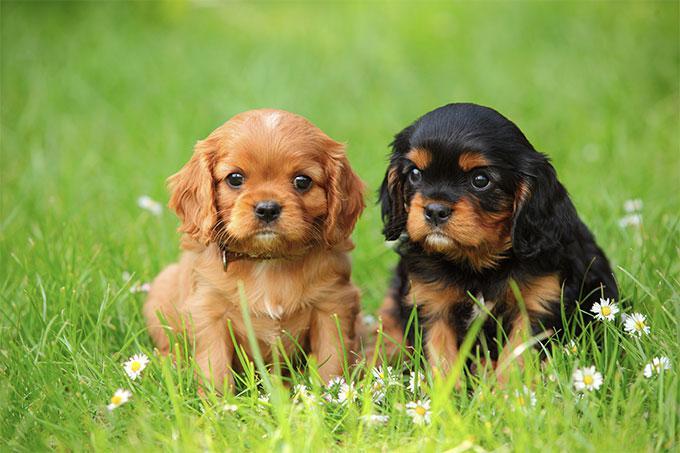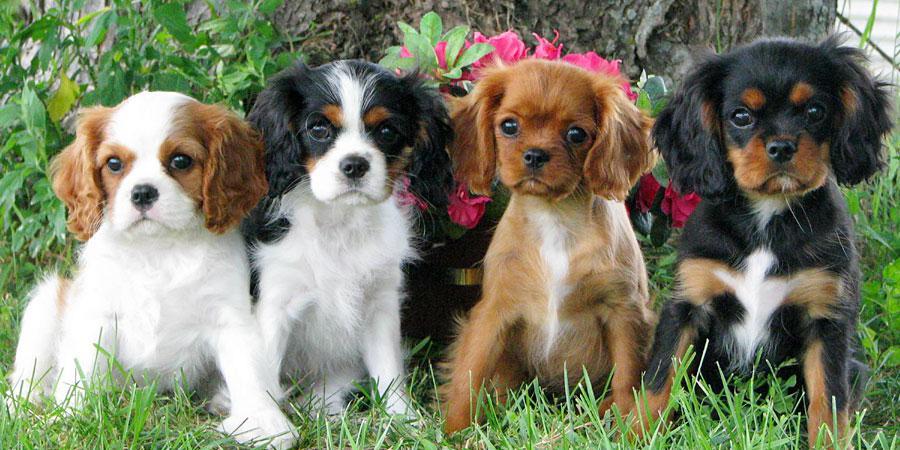The first image is the image on the left, the second image is the image on the right. Considering the images on both sides, is "There is exactly one dog with black and white fur." valid? Answer yes or no. No. The first image is the image on the left, the second image is the image on the right. Analyze the images presented: Is the assertion "Pinkish flowers are in the background behind at least one dog that is sitting upright." valid? Answer yes or no. Yes. 